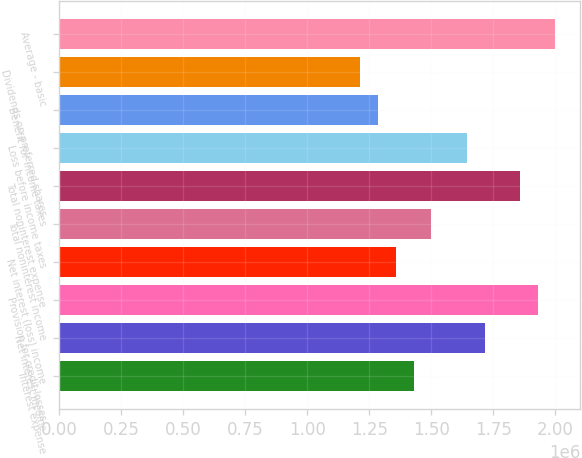Convert chart. <chart><loc_0><loc_0><loc_500><loc_500><bar_chart><fcel>Interest expense<fcel>Net interest income<fcel>Provision for credit losses<fcel>Net interest (loss) income<fcel>Total noninterest income<fcel>Total noninterest expense<fcel>Loss before income taxes<fcel>Benefit for income taxes<fcel>Dividends on preferred shares<fcel>Average - basic<nl><fcel>1.42894e+06<fcel>1.71473e+06<fcel>1.92907e+06<fcel>1.35749e+06<fcel>1.50038e+06<fcel>1.85762e+06<fcel>1.64328e+06<fcel>1.28604e+06<fcel>1.2146e+06<fcel>2.00051e+06<nl></chart> 